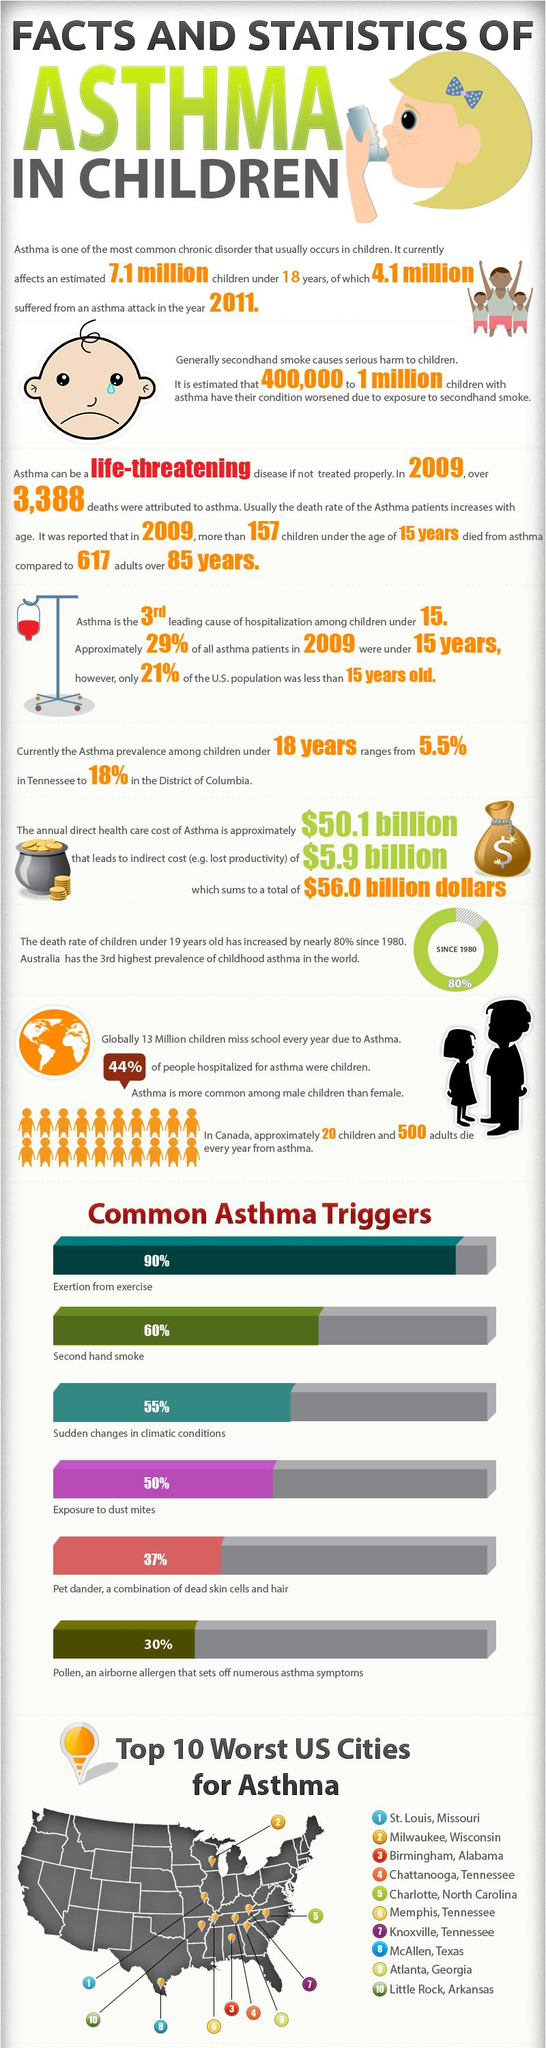Give some essential details in this illustration. Exposure to second-hand smoke and dust mites has been linked to a high incidence of asthma. Studies suggest that the percentage of asthma cases attributed to second-hand smoke and dust mites exposure is approximately 110%. It is estimated that asthma accounts for approximately 150% of cases that are caused by secondary exposure to dust from shaking and exertion during exercise. According to the provided data, 56% of those hospitalized for asthma were not children. 